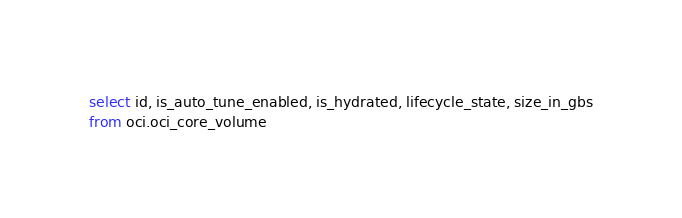Convert code to text. <code><loc_0><loc_0><loc_500><loc_500><_SQL_>select id, is_auto_tune_enabled, is_hydrated, lifecycle_state, size_in_gbs
from oci.oci_core_volume</code> 